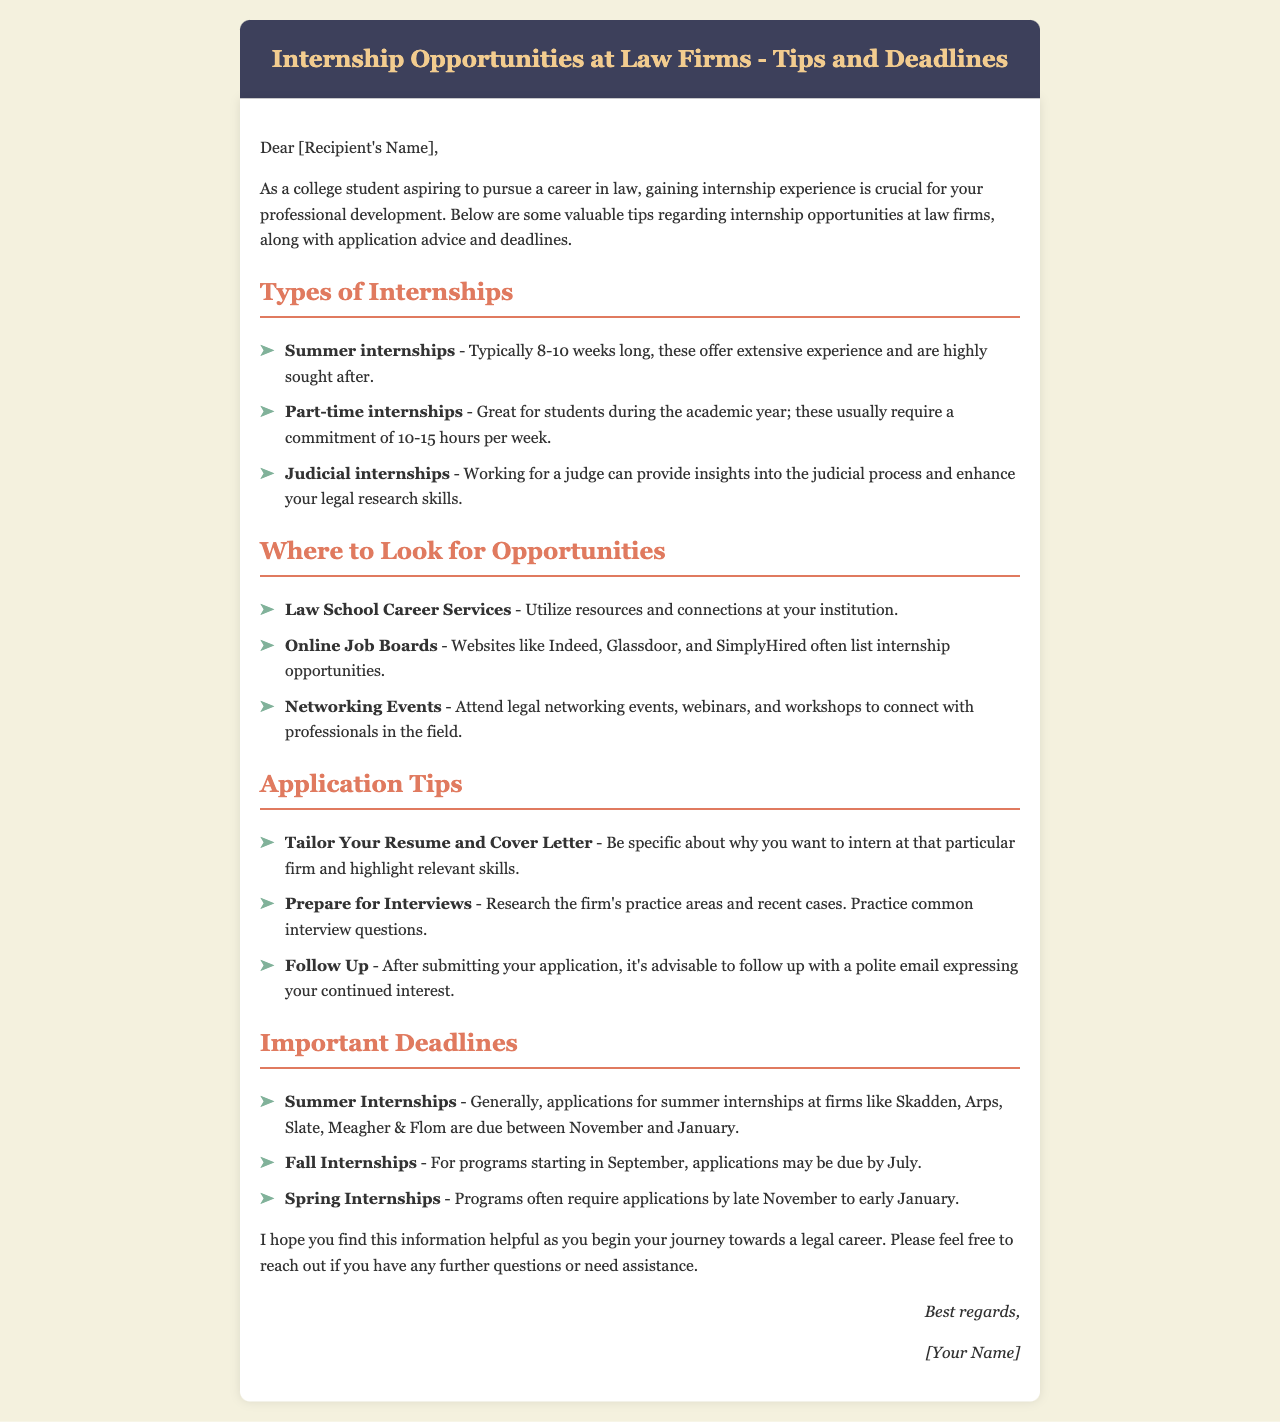What type of internships are typically 8-10 weeks long? The document mentions summer internships that usually last for 8-10 weeks.
Answer: Summer internships What resource can you utilize at your institution for internship opportunities? The document states that law school career services can be utilized for resources and connections.
Answer: Law School Career Services What should you do after submitting your application? It is advised in the document to follow up with a polite email expressing continued interest after submitting an application.
Answer: Follow Up When are applications for summer internships generally due? The document indicates that applications for summer internships are typically due between November and January.
Answer: November to January What is one of the key application tips mentioned? One key application tip highlighted is to tailor your resume and cover letter specifically for the firm.
Answer: Tailor Your Resume and Cover Letter How many hours per week does a part-time internship usually require? According to the document, part-time internships usually require a commitment of 10-15 hours per week.
Answer: 10-15 hours per week What is the main purpose of this email? The email is aimed at providing valuable tips regarding internship opportunities at law firms.
Answer: Provide valuable tips What is the color of the header background in the document? The header background color is mentioned in the document as dark blue (#3d405b).
Answer: Dark blue What type of internships can enhance your legal research skills? The document specifies that judicial internships can enhance your legal research skills.
Answer: Judicial internships 